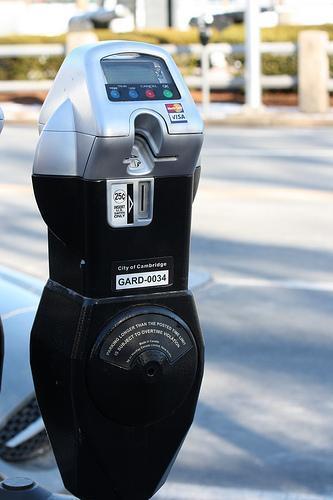How many meters are there?
Give a very brief answer. 1. 